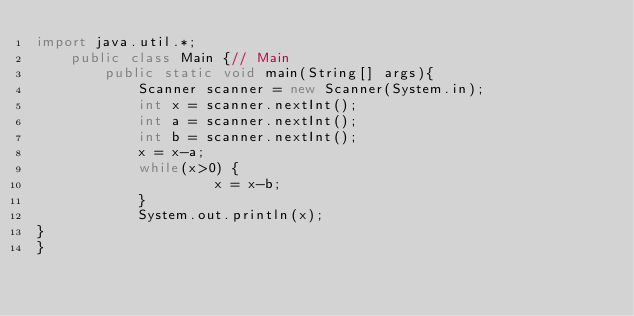<code> <loc_0><loc_0><loc_500><loc_500><_Java_>import java.util.*;
    public class Main {// Main
        public static void main(String[] args){
            Scanner scanner = new Scanner(System.in);
            int x = scanner.nextInt();
            int a = scanner.nextInt();
            int b = scanner.nextInt();
            x = x-a;
            while(x>0) {
                     x = x-b;
            }
            System.out.println(x);
}
}</code> 